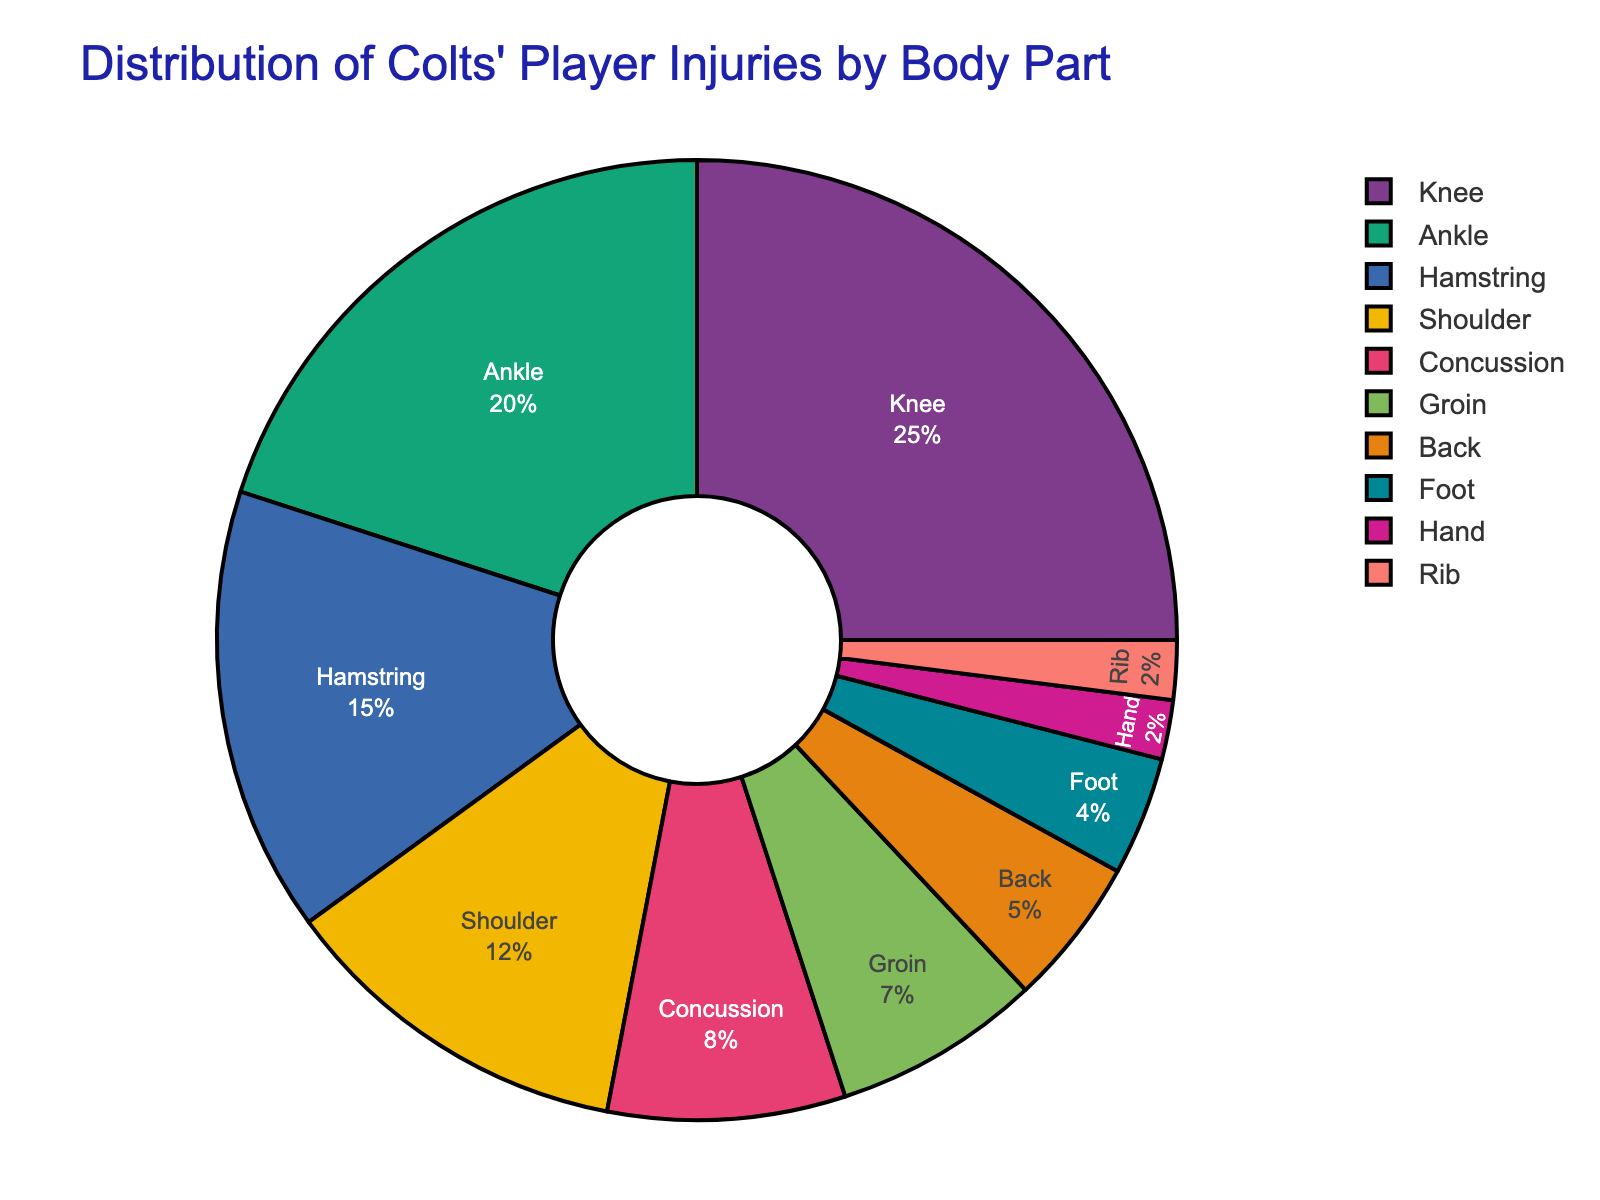Which body part has the highest percentage of injuries? Locate the largest segment in the pie chart. The segment for the knee is the largest, indicating it has the highest percentage of injuries among Colts' players.
Answer: Knee Which body parts combined account for more than half of the injuries? Identify the segments that, when summed up, account for more than 50%. The knee (25%) and ankle (20%) together make 45%, adding the hamstring (15%) reaches 60%, which is more than half.
Answer: Knee, Ankle, Hamstring What is the percentage difference between ankle and shoulder injuries? Find the percentages for ankle (20%) and shoulder (12%), then subtract the smaller from the larger: 20% - 12% = 8%.
Answer: 8% Do more players suffer from concussions or back injuries? Compare the segments for concussions (8%) and back (5%). The concussion segment is larger.
Answer: Concussions Which injury types occur less frequently than hamstring injuries? Identify segments with percentages lower than the hamstring (15%): shoulder (12%), concussion (8%), groin (7%), back (5%), foot (4%), hand (2%), and rib (2%).
Answer: Shoulder, Concussion, Groin, Back, Foot, Hand, Rib What is the combined percentage for injuries to the foot, hand, and rib? Add the percentages for foot (4%), hand (2%), and rib (2%): 4% + 2% + 2% = 8%.
Answer: 8% How does the percentage of shoulder injuries compare to that of groin injuries? Compare the percentages for shoulder (12%) and groin (7%). Shoulder injuries account for a higher percentage.
Answer: Shoulder injuries are higher Which segment represents the smallest percentage of injuries? Identify the smallest segment. Both hand and rib segments are the smallest, both at 2%.
Answer: Hand, Rib What is the ratio of knee injuries to back injuries? Determine the percentages for knee (25%) and back (5%). The ratio is 25%/5% or 25:5, which simplifies to 5:1.
Answer: 5:1 Is the percentage of shoulder injuries greater than the combined percentage of foot and hand injuries? Compare shoulder injuries (12%) with the combined foot (4%) and hand (2%) injuries: 12% compared to (4% + 2% = 6%). Shoulder injuries account for a higher percentage.
Answer: Yes 